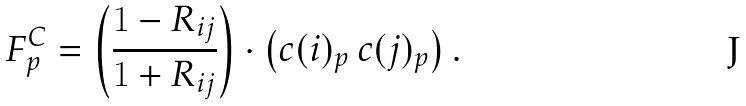Convert formula to latex. <formula><loc_0><loc_0><loc_500><loc_500>F ^ { C } _ { p } = \left ( \frac { 1 - R _ { i j } } { 1 + R _ { i j } } \right ) \cdot \left ( c ( i ) _ { p } \, c ( j ) _ { p } \right ) .</formula> 